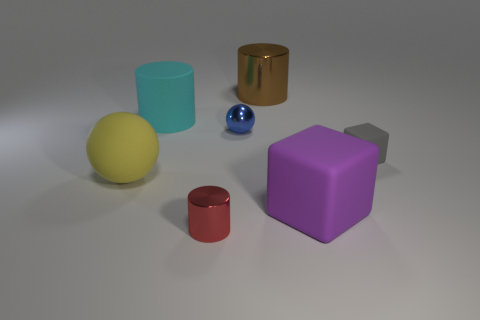Add 2 brown cylinders. How many objects exist? 9 Subtract all balls. How many objects are left? 5 Add 7 small blue metallic spheres. How many small blue metallic spheres are left? 8 Add 7 large matte blocks. How many large matte blocks exist? 8 Subtract 1 blue spheres. How many objects are left? 6 Subtract all large gray metallic objects. Subtract all small things. How many objects are left? 4 